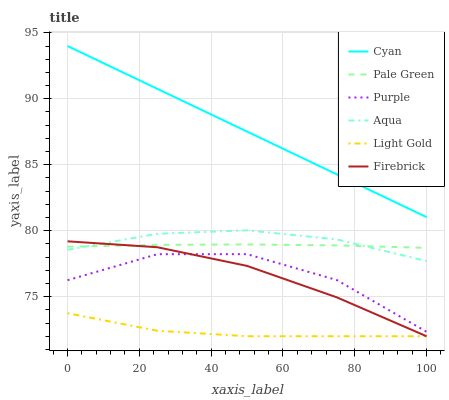Does Light Gold have the minimum area under the curve?
Answer yes or no. Yes. Does Cyan have the maximum area under the curve?
Answer yes or no. Yes. Does Firebrick have the minimum area under the curve?
Answer yes or no. No. Does Firebrick have the maximum area under the curve?
Answer yes or no. No. Is Cyan the smoothest?
Answer yes or no. Yes. Is Purple the roughest?
Answer yes or no. Yes. Is Firebrick the smoothest?
Answer yes or no. No. Is Firebrick the roughest?
Answer yes or no. No. Does Firebrick have the lowest value?
Answer yes or no. Yes. Does Aqua have the lowest value?
Answer yes or no. No. Does Cyan have the highest value?
Answer yes or no. Yes. Does Firebrick have the highest value?
Answer yes or no. No. Is Aqua less than Cyan?
Answer yes or no. Yes. Is Cyan greater than Aqua?
Answer yes or no. Yes. Does Firebrick intersect Pale Green?
Answer yes or no. Yes. Is Firebrick less than Pale Green?
Answer yes or no. No. Is Firebrick greater than Pale Green?
Answer yes or no. No. Does Aqua intersect Cyan?
Answer yes or no. No. 